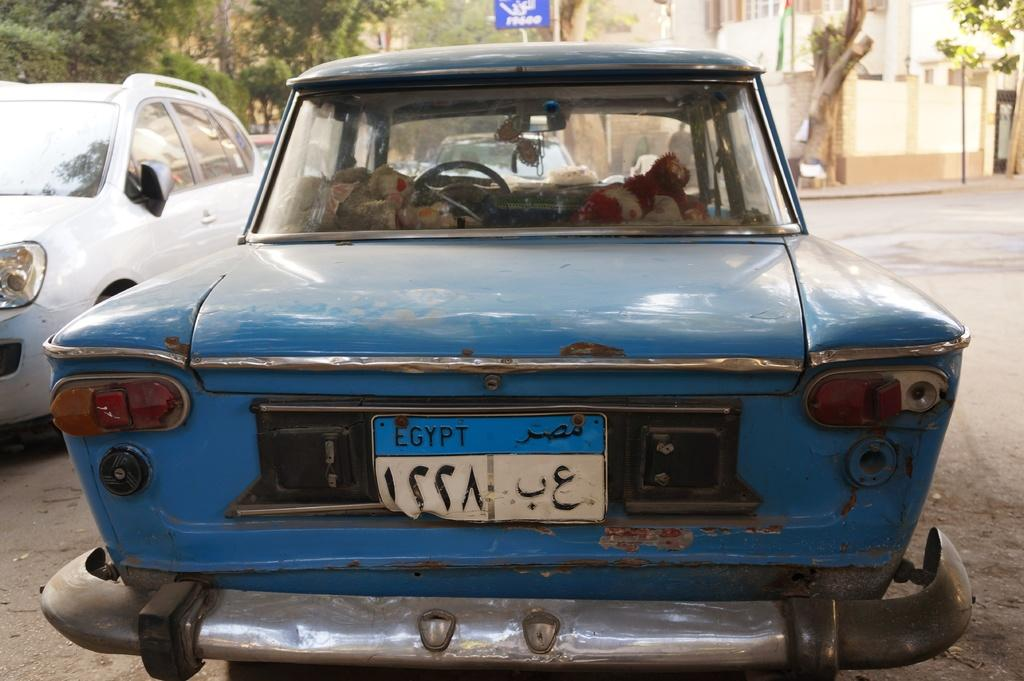What type of vehicles can be seen in the image? There are cars in the image. What is located behind the cars? There is a board behind the cars. What can be seen in the distance in the image? There are trees and buildings in the background of the image. What type of cabbage is growing in the image? There is no cabbage present in the image. What type of society is depicted in the image? The image does not depict a society; it shows cars, a board, trees, and buildings. 